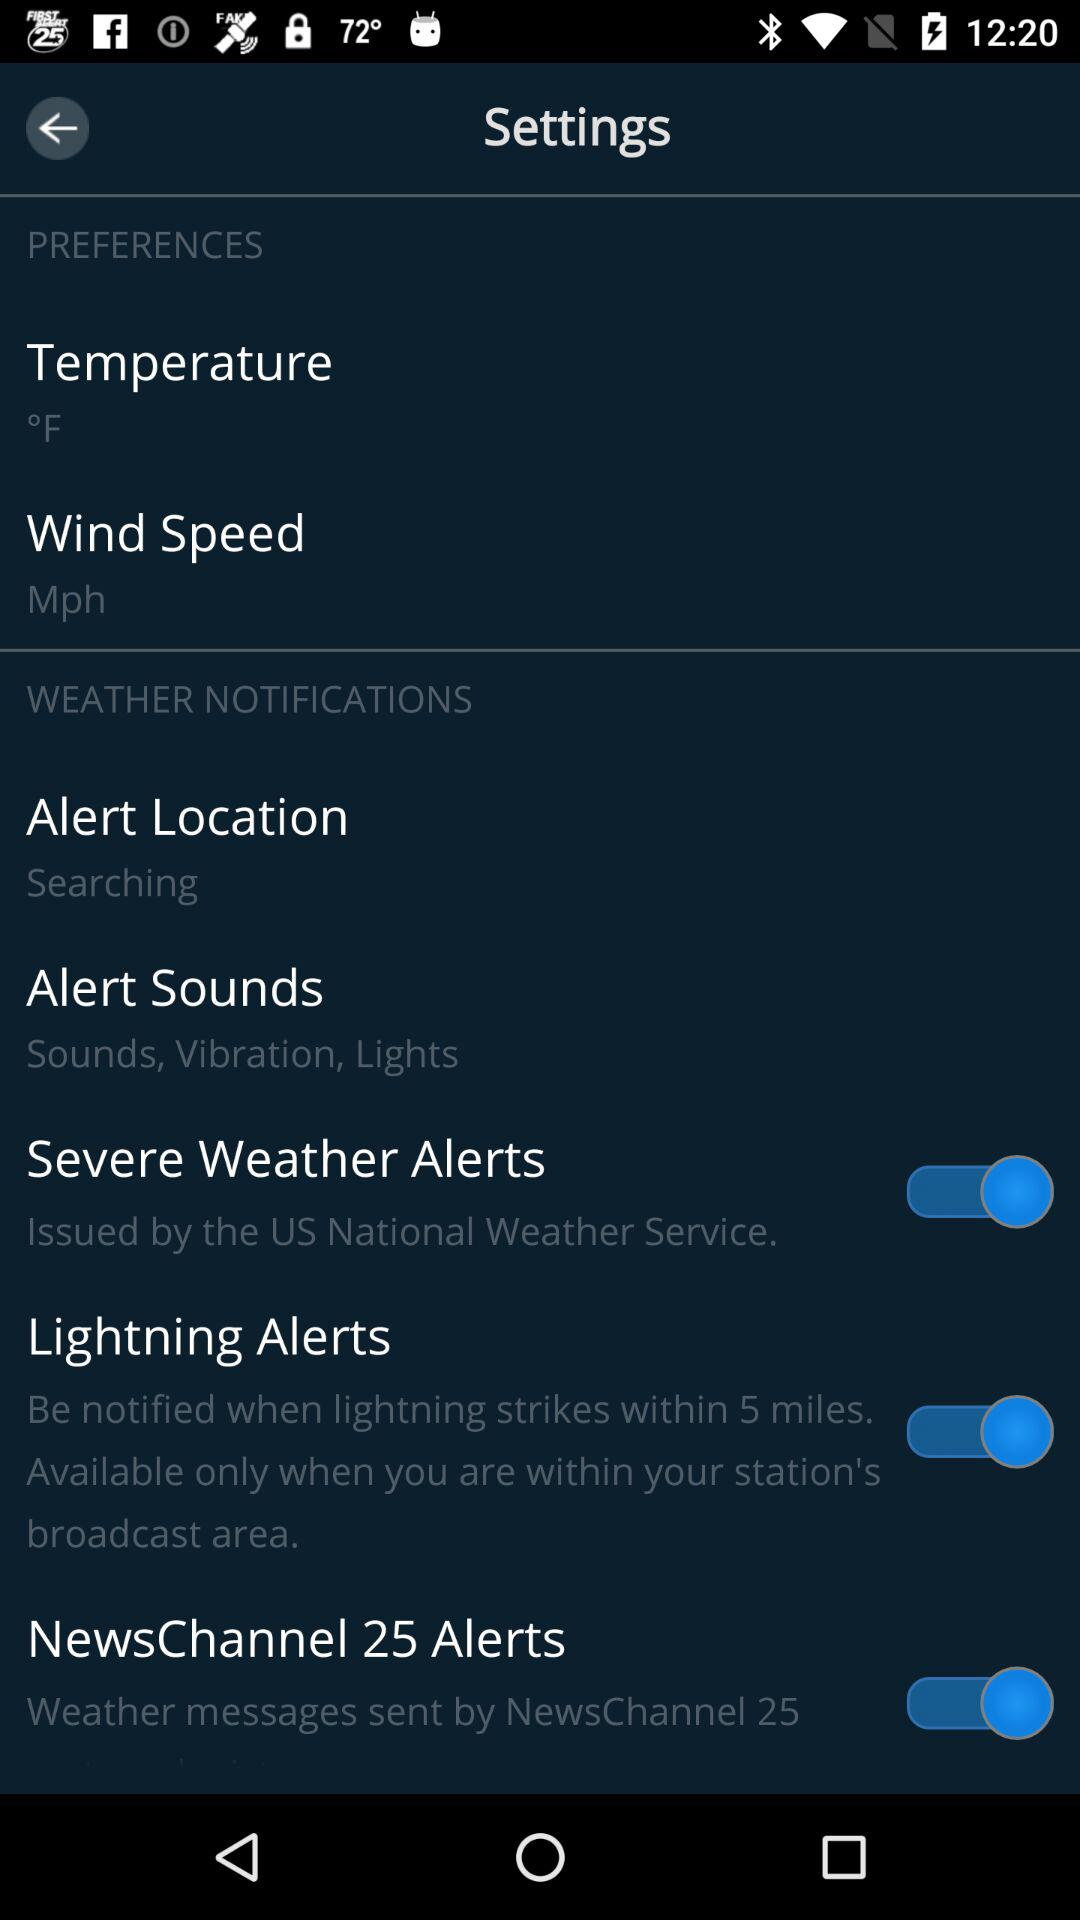What is the status of "NewsChannel 25 Alerts"? The status of "NewsChannel 25 Alerts" is "on". 